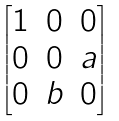<formula> <loc_0><loc_0><loc_500><loc_500>\begin{bmatrix} 1 & 0 & 0 \\ 0 & 0 & a \\ 0 & b & 0 \\ \end{bmatrix}</formula> 